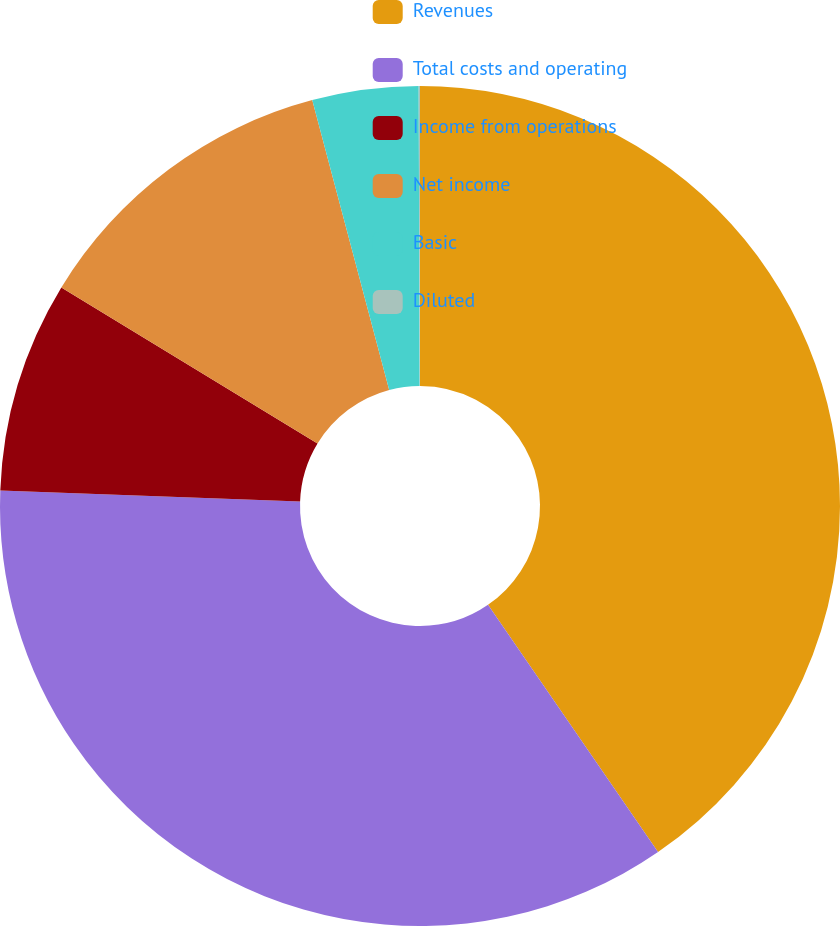<chart> <loc_0><loc_0><loc_500><loc_500><pie_chart><fcel>Revenues<fcel>Total costs and operating<fcel>Income from operations<fcel>Net income<fcel>Basic<fcel>Diluted<nl><fcel>40.41%<fcel>35.18%<fcel>8.12%<fcel>12.16%<fcel>4.08%<fcel>0.05%<nl></chart> 